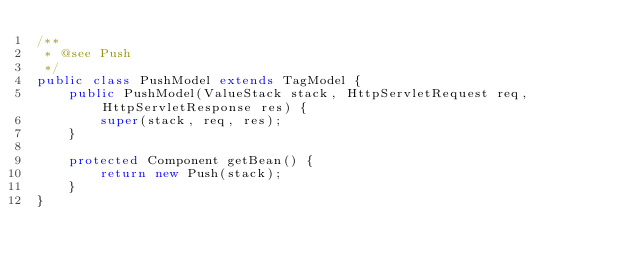Convert code to text. <code><loc_0><loc_0><loc_500><loc_500><_Java_>/**
 * @see Push
 */
public class PushModel extends TagModel {
    public PushModel(ValueStack stack, HttpServletRequest req, HttpServletResponse res) {
        super(stack, req, res);
    }

    protected Component getBean() {
        return new Push(stack);
    }
}
</code> 